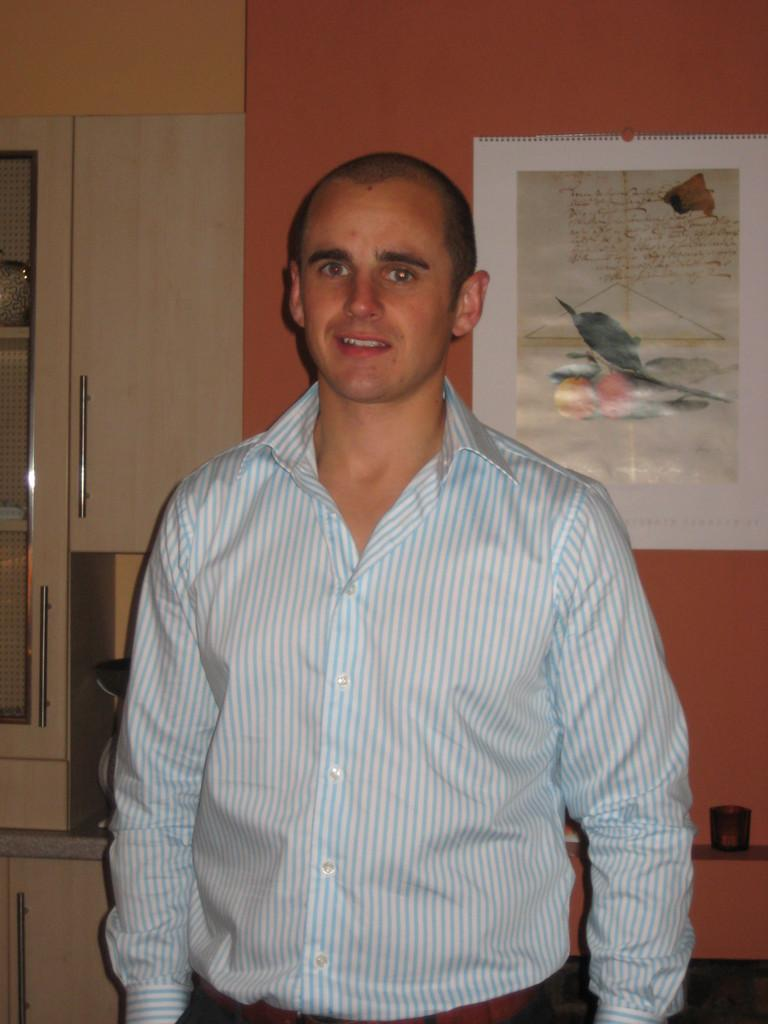Who is in the picture? There is a man in the picture. What is the man doing in the picture? The man is standing in the picture. What expression does the man have on his face? The man is smiling in the picture. What is the man wearing in the picture? The man is wearing a shirt in the picture. What can be seen in the background of the picture? There is a poster attached to the wall in the background, and there are other objects visible as well. What type of birthday celebration is happening in the picture? There is no indication of a birthday celebration in the picture; it simply shows a man standing and smiling. 